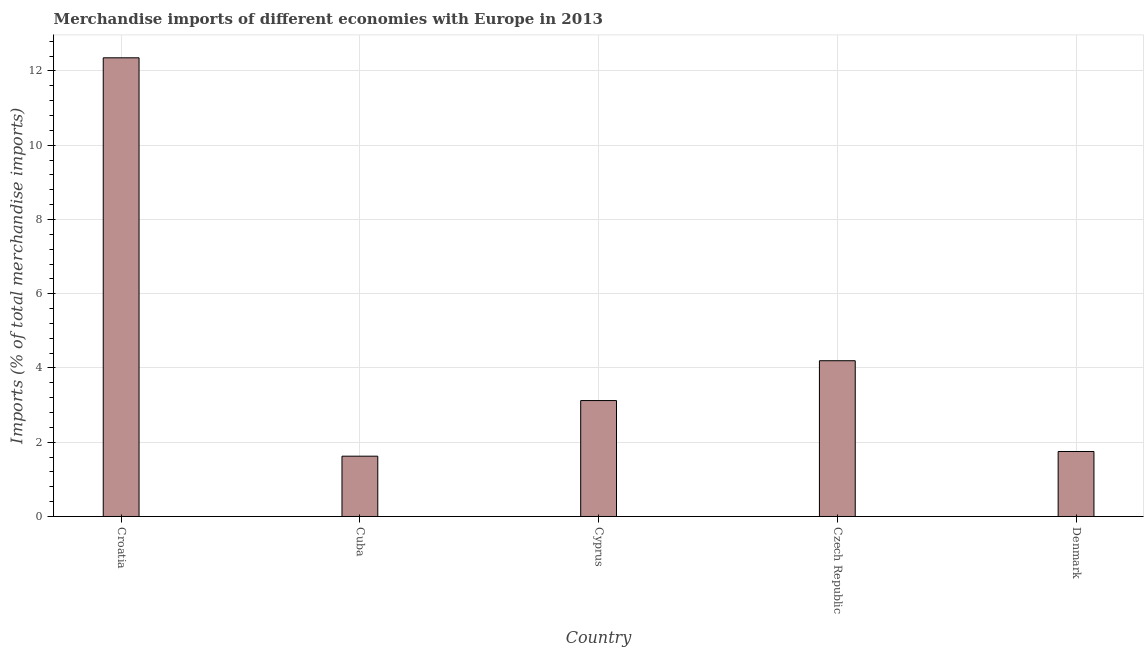Does the graph contain any zero values?
Ensure brevity in your answer.  No. What is the title of the graph?
Offer a very short reply. Merchandise imports of different economies with Europe in 2013. What is the label or title of the Y-axis?
Your answer should be very brief. Imports (% of total merchandise imports). What is the merchandise imports in Croatia?
Make the answer very short. 12.35. Across all countries, what is the maximum merchandise imports?
Provide a succinct answer. 12.35. Across all countries, what is the minimum merchandise imports?
Offer a very short reply. 1.62. In which country was the merchandise imports maximum?
Provide a succinct answer. Croatia. In which country was the merchandise imports minimum?
Provide a short and direct response. Cuba. What is the sum of the merchandise imports?
Offer a terse response. 23.05. What is the difference between the merchandise imports in Croatia and Czech Republic?
Your answer should be very brief. 8.16. What is the average merchandise imports per country?
Ensure brevity in your answer.  4.61. What is the median merchandise imports?
Provide a short and direct response. 3.12. What is the ratio of the merchandise imports in Croatia to that in Denmark?
Your answer should be very brief. 7.06. Is the merchandise imports in Cyprus less than that in Czech Republic?
Your response must be concise. Yes. What is the difference between the highest and the second highest merchandise imports?
Ensure brevity in your answer.  8.16. Is the sum of the merchandise imports in Cuba and Cyprus greater than the maximum merchandise imports across all countries?
Offer a very short reply. No. What is the difference between the highest and the lowest merchandise imports?
Make the answer very short. 10.73. How many bars are there?
Keep it short and to the point. 5. What is the Imports (% of total merchandise imports) in Croatia?
Your answer should be compact. 12.35. What is the Imports (% of total merchandise imports) of Cuba?
Keep it short and to the point. 1.62. What is the Imports (% of total merchandise imports) in Cyprus?
Offer a terse response. 3.12. What is the Imports (% of total merchandise imports) in Czech Republic?
Your answer should be compact. 4.2. What is the Imports (% of total merchandise imports) in Denmark?
Keep it short and to the point. 1.75. What is the difference between the Imports (% of total merchandise imports) in Croatia and Cuba?
Give a very brief answer. 10.73. What is the difference between the Imports (% of total merchandise imports) in Croatia and Cyprus?
Your answer should be compact. 9.23. What is the difference between the Imports (% of total merchandise imports) in Croatia and Czech Republic?
Your answer should be very brief. 8.16. What is the difference between the Imports (% of total merchandise imports) in Croatia and Denmark?
Offer a terse response. 10.6. What is the difference between the Imports (% of total merchandise imports) in Cuba and Cyprus?
Make the answer very short. -1.5. What is the difference between the Imports (% of total merchandise imports) in Cuba and Czech Republic?
Keep it short and to the point. -2.57. What is the difference between the Imports (% of total merchandise imports) in Cuba and Denmark?
Keep it short and to the point. -0.13. What is the difference between the Imports (% of total merchandise imports) in Cyprus and Czech Republic?
Your answer should be compact. -1.07. What is the difference between the Imports (% of total merchandise imports) in Cyprus and Denmark?
Ensure brevity in your answer.  1.37. What is the difference between the Imports (% of total merchandise imports) in Czech Republic and Denmark?
Give a very brief answer. 2.44. What is the ratio of the Imports (% of total merchandise imports) in Croatia to that in Cuba?
Keep it short and to the point. 7.61. What is the ratio of the Imports (% of total merchandise imports) in Croatia to that in Cyprus?
Provide a short and direct response. 3.96. What is the ratio of the Imports (% of total merchandise imports) in Croatia to that in Czech Republic?
Your answer should be compact. 2.94. What is the ratio of the Imports (% of total merchandise imports) in Croatia to that in Denmark?
Offer a terse response. 7.06. What is the ratio of the Imports (% of total merchandise imports) in Cuba to that in Cyprus?
Give a very brief answer. 0.52. What is the ratio of the Imports (% of total merchandise imports) in Cuba to that in Czech Republic?
Provide a succinct answer. 0.39. What is the ratio of the Imports (% of total merchandise imports) in Cuba to that in Denmark?
Provide a short and direct response. 0.93. What is the ratio of the Imports (% of total merchandise imports) in Cyprus to that in Czech Republic?
Offer a very short reply. 0.74. What is the ratio of the Imports (% of total merchandise imports) in Cyprus to that in Denmark?
Keep it short and to the point. 1.78. What is the ratio of the Imports (% of total merchandise imports) in Czech Republic to that in Denmark?
Offer a very short reply. 2.4. 